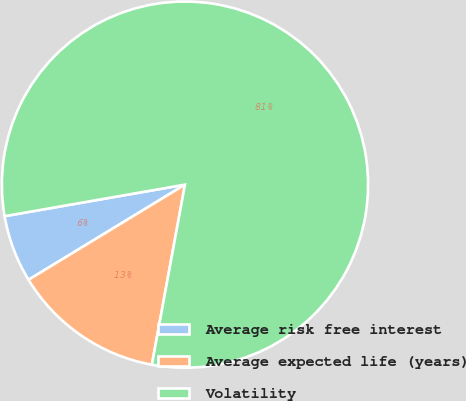Convert chart to OTSL. <chart><loc_0><loc_0><loc_500><loc_500><pie_chart><fcel>Average risk free interest<fcel>Average expected life (years)<fcel>Volatility<nl><fcel>5.94%<fcel>13.41%<fcel>80.65%<nl></chart> 